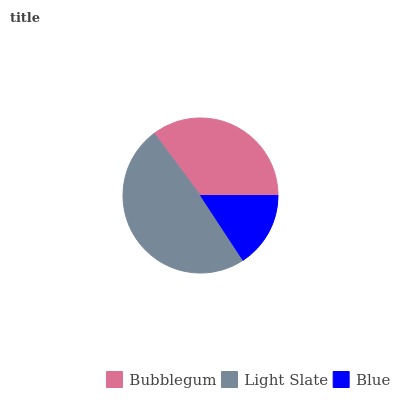Is Blue the minimum?
Answer yes or no. Yes. Is Light Slate the maximum?
Answer yes or no. Yes. Is Light Slate the minimum?
Answer yes or no. No. Is Blue the maximum?
Answer yes or no. No. Is Light Slate greater than Blue?
Answer yes or no. Yes. Is Blue less than Light Slate?
Answer yes or no. Yes. Is Blue greater than Light Slate?
Answer yes or no. No. Is Light Slate less than Blue?
Answer yes or no. No. Is Bubblegum the high median?
Answer yes or no. Yes. Is Bubblegum the low median?
Answer yes or no. Yes. Is Light Slate the high median?
Answer yes or no. No. Is Light Slate the low median?
Answer yes or no. No. 